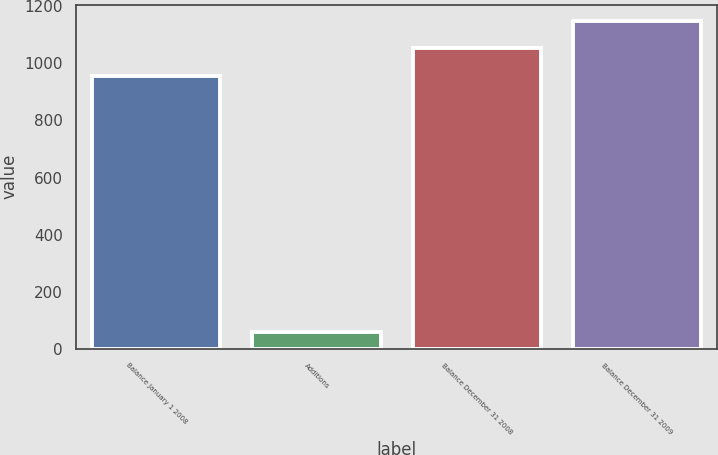Convert chart. <chart><loc_0><loc_0><loc_500><loc_500><bar_chart><fcel>Balance January 1 2008<fcel>Additions<fcel>Balance December 31 2008<fcel>Balance December 31 2009<nl><fcel>957<fcel>58<fcel>1052.7<fcel>1148.4<nl></chart> 